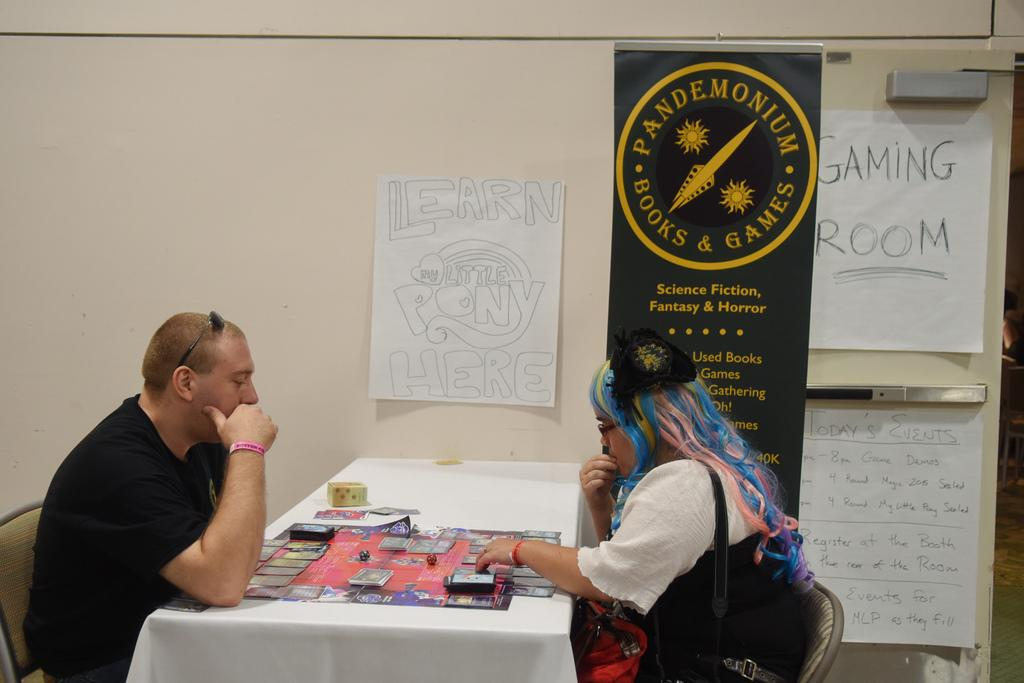What is the man doing in the image? The man is sitting on a chair on the left side of the image. What is the man's focus in the image? The man is looking towards the middle of the image. What is the woman doing in the image? The woman is on the right side of the image. What is the woman wearing in the image? The woman is wearing a white dress. What rate of liquid is being measured by the man in the image? There is no indication in the image that the man is measuring any liquid, so it cannot be determined from the picture. 